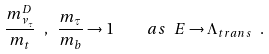Convert formula to latex. <formula><loc_0><loc_0><loc_500><loc_500>\frac { m ^ { D } _ { \nu _ { \tau } } } { m _ { t } } \ , \ \frac { m _ { \tau } } { m _ { b } } \rightarrow 1 \quad a s \ E \rightarrow \Lambda _ { t r a n s } \ .</formula> 